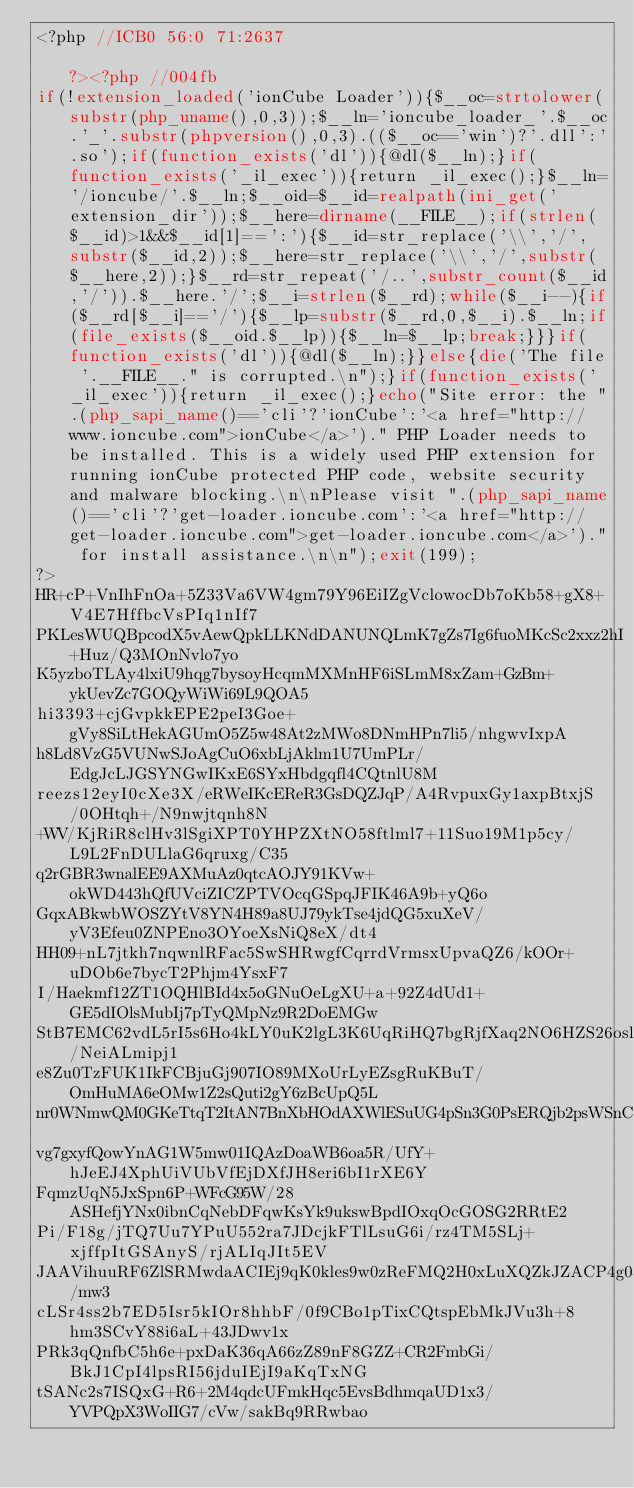<code> <loc_0><loc_0><loc_500><loc_500><_PHP_><?php //ICB0 56:0 71:2637                                                     ?><?php //004fb
if(!extension_loaded('ionCube Loader')){$__oc=strtolower(substr(php_uname(),0,3));$__ln='ioncube_loader_'.$__oc.'_'.substr(phpversion(),0,3).(($__oc=='win')?'.dll':'.so');if(function_exists('dl')){@dl($__ln);}if(function_exists('_il_exec')){return _il_exec();}$__ln='/ioncube/'.$__ln;$__oid=$__id=realpath(ini_get('extension_dir'));$__here=dirname(__FILE__);if(strlen($__id)>1&&$__id[1]==':'){$__id=str_replace('\\','/',substr($__id,2));$__here=str_replace('\\','/',substr($__here,2));}$__rd=str_repeat('/..',substr_count($__id,'/')).$__here.'/';$__i=strlen($__rd);while($__i--){if($__rd[$__i]=='/'){$__lp=substr($__rd,0,$__i).$__ln;if(file_exists($__oid.$__lp)){$__ln=$__lp;break;}}}if(function_exists('dl')){@dl($__ln);}}else{die('The file '.__FILE__." is corrupted.\n");}if(function_exists('_il_exec')){return _il_exec();}echo("Site error: the ".(php_sapi_name()=='cli'?'ionCube':'<a href="http://www.ioncube.com">ionCube</a>')." PHP Loader needs to be installed. This is a widely used PHP extension for running ionCube protected PHP code, website security and malware blocking.\n\nPlease visit ".(php_sapi_name()=='cli'?'get-loader.ioncube.com':'<a href="http://get-loader.ioncube.com">get-loader.ioncube.com</a>')." for install assistance.\n\n");exit(199);
?>
HR+cP+VnIhFnOa+5Z33Va6VW4gm79Y96EiIZgVclowocDb7oKb58+gX8+V4E7HffbcVsPIq1nIf7
PKLesWUQBpcodX5vAewQpkLLKNdDANUNQLmK7gZs7Ig6fuoMKcSc2xxz2hI+Huz/Q3MOnNvlo7yo
K5yzboTLAy4lxiU9hqg7bysoyHcqmMXMnHF6iSLmM8xZam+GzBm+ykUevZc7GOQyWiWi69L9QOA5
hi3393+cjGvpkkEPE2peI3Goe+gVy8SiLtHekAGUmO5Z5w48At2zMWo8DNmHPn7li5/nhgwvIxpA
h8Ld8VzG5VUNwSJoAgCuO6xbLjAklm1U7UmPLr/EdgJcLJGSYNGwIKxE6SYxHbdgqfl4CQtnlU8M
reezs12eyI0cXe3X/eRWeIKcEReR3GsDQZJqP/A4RvpuxGy1axpBtxjS/0OHtqh+/N9nwjtqnh8N
+WV/KjRiR8clHv3lSgiXPT0YHPZXtNO58ftlml7+11Suo19M1p5cy/L9L2FnDULlaG6qruxg/C35
q2rGBR3wnalEE9AXMuAz0qtcAOJY91KVw+okWD443hQfUVciZICZPTVOcqGSpqJFIK46A9b+yQ6o
GqxABkwbWOSZYtV8YN4H89a8UJ79ykTse4jdQG5xuXeV/yV3Efeu0ZNPEno3OYoeXsNiQ8eX/dt4
HH09+nL7jtkh7nqwnlRFac5SwSHRwgfCqrrdVrmsxUpvaQZ6/kOOr+uDOb6e7bycT2Phjm4YsxF7
I/Haekmf12ZT1OQHlBId4x5oGNuOeLgXU+a+92Z4dUd1+GE5dIOlsMubIj7pTyQMpNz9R2DoEMGw
StB7EMC62vdL5rI5s6Ho4kLY0uK2lgL3K6UqRiHQ7bgRjfXaq2NO6HZS26oslmFcM/NeiALmipj1
e8Zu0TzFUK1IkFCBjuGj907IO89MXoUrLyEZsgRuKBuT/OmHuMA6eOMw1Z2sQuti2gY6zBcUpQ5L
nr0WNmwQM0GKeTtqT2ItAN7BnXbHOdAXWlESuUG4pSn3G0PsERQjb2psWSnC5Lf2gMGKDzJrHqWO
vg7gxyfQowYnAG1W5mw01IQAzDoaWB6oa5R/UfY+hJeEJ4XphUiVUbVfEjDXfJH8eri6bI1rXE6Y
FqmzUqN5JxSpn6P+WFcG95W/28ASHefjYNx0ibnCqNebDFqwKsYk9ukswBpdIOxqOcGOSG2RRtE2
Pi/F18g/jTQ7Uu7YPuU552ra7JDcjkFTlLsuG6i/rz4TM5SLj+xjffpItGSAnyS/rjALIqJIt5EV
JAAVihuuRF6ZlSRMwdaACIEj9qK0kles9w0zReFMQ2H0xLuXQZkJZACP4g08M6TdCITeIyfI/mw3
cLSr4ss2b7ED5Isr5kIOr8hhbF/0f9CBo1pTixCQtspEbMkJVu3h+8hm3SCvY88i6aL+43JDwv1x
PRk3qQnfbC5h6e+pxDaK36qA66zZ89nF8GZZ+CR2FmbGi/BkJ1CpI4lpsRI56jduIEjI9aKqTxNG
tSANc2s7ISQxG+R6+2M4qdcUFmkHqc5EvsBdhmqaUD1x3/YVPQpX3WoIIG7/cVw/sakBq9RRwbao</code> 